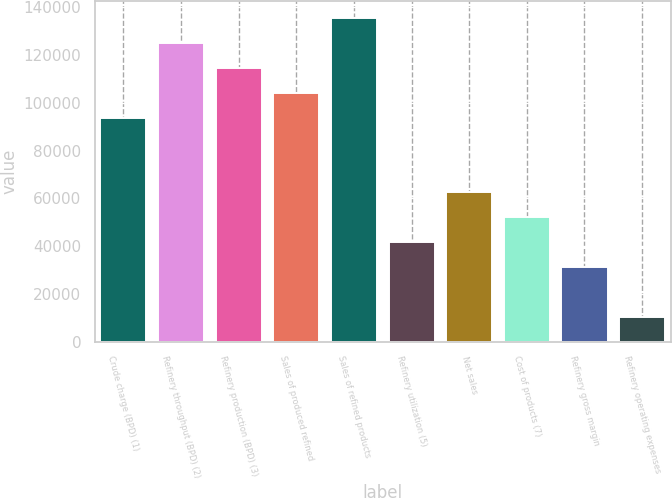<chart> <loc_0><loc_0><loc_500><loc_500><bar_chart><fcel>Crude charge (BPD) (1)<fcel>Refinery throughput (BPD) (2)<fcel>Refinery production (BPD) (3)<fcel>Sales of produced refined<fcel>Sales of refined products<fcel>Refinery utilization (5)<fcel>Net sales<fcel>Cost of products (7)<fcel>Refinery gross margin<fcel>Refinery operating expenses<nl><fcel>93830<fcel>125214<fcel>114753<fcel>104291<fcel>135676<fcel>41851.5<fcel>62774.4<fcel>52312.9<fcel>31390.1<fcel>10467.3<nl></chart> 